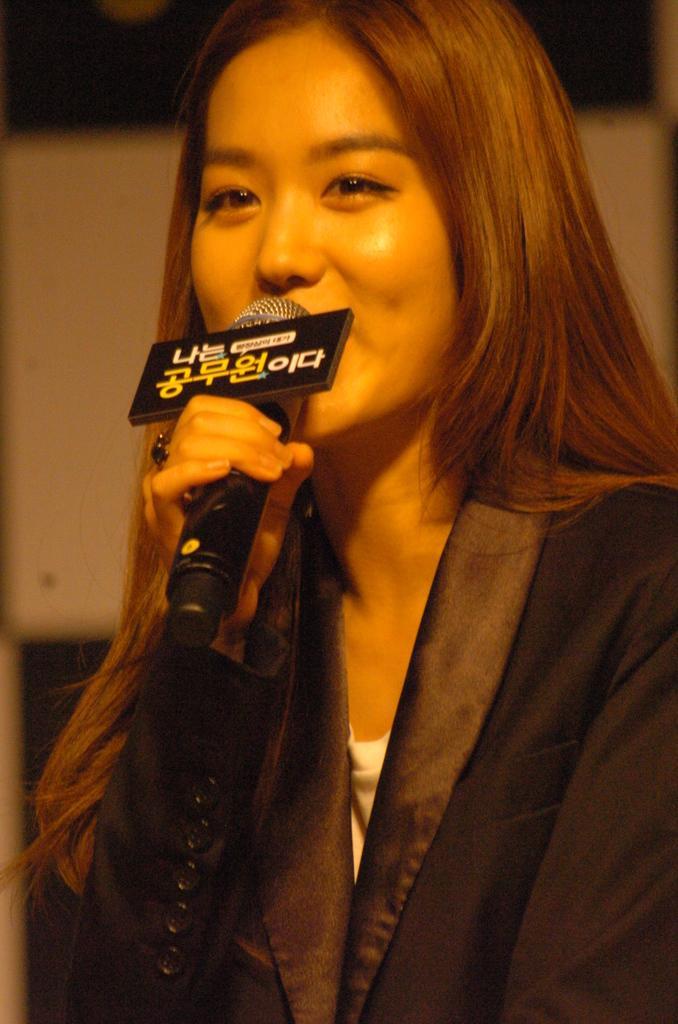Describe this image in one or two sentences. In this image I can see a woman holding a mike in her hands and it seems like he's speaking something. 